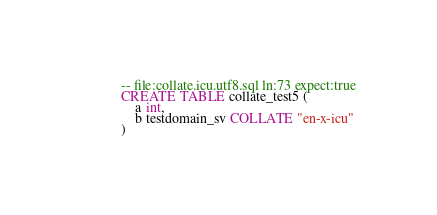<code> <loc_0><loc_0><loc_500><loc_500><_SQL_>-- file:collate.icu.utf8.sql ln:73 expect:true
CREATE TABLE collate_test5 (
    a int,
    b testdomain_sv COLLATE "en-x-icu"
)
</code> 